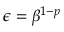<formula> <loc_0><loc_0><loc_500><loc_500>\epsilon = \beta ^ { 1 - p }</formula> 